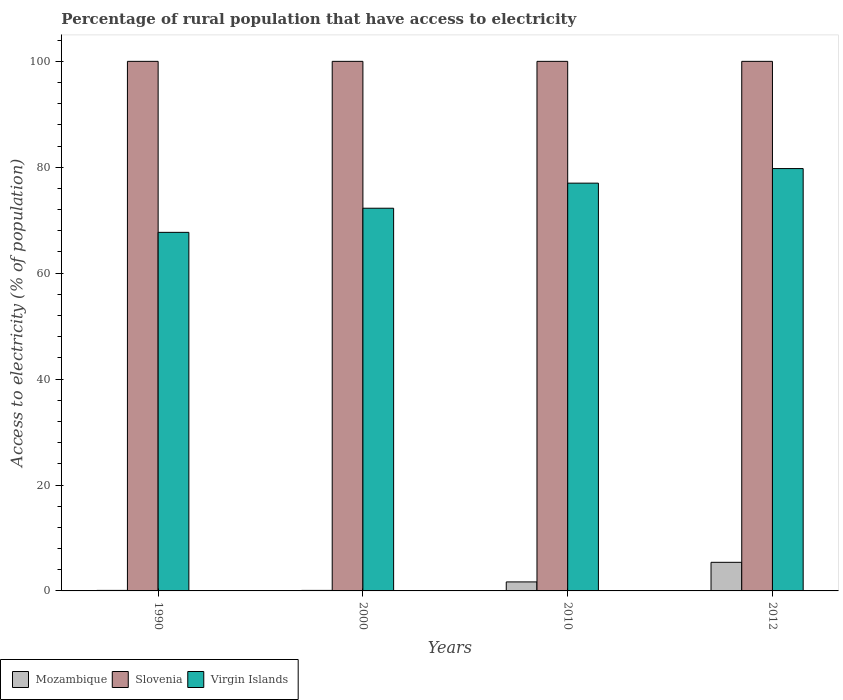Are the number of bars per tick equal to the number of legend labels?
Offer a very short reply. Yes. How many bars are there on the 3rd tick from the left?
Give a very brief answer. 3. How many bars are there on the 4th tick from the right?
Provide a succinct answer. 3. What is the label of the 4th group of bars from the left?
Provide a short and direct response. 2012. What is the percentage of rural population that have access to electricity in Virgin Islands in 2010?
Offer a very short reply. 77. Across all years, what is the maximum percentage of rural population that have access to electricity in Virgin Islands?
Ensure brevity in your answer.  79.75. Across all years, what is the minimum percentage of rural population that have access to electricity in Slovenia?
Your answer should be compact. 100. What is the total percentage of rural population that have access to electricity in Mozambique in the graph?
Your answer should be compact. 7.3. What is the difference between the percentage of rural population that have access to electricity in Virgin Islands in 2000 and that in 2010?
Your response must be concise. -4.73. What is the difference between the percentage of rural population that have access to electricity in Mozambique in 2000 and the percentage of rural population that have access to electricity in Virgin Islands in 1990?
Provide a succinct answer. -67.61. What is the average percentage of rural population that have access to electricity in Virgin Islands per year?
Make the answer very short. 74.18. In the year 2000, what is the difference between the percentage of rural population that have access to electricity in Mozambique and percentage of rural population that have access to electricity in Slovenia?
Your answer should be compact. -99.9. What is the ratio of the percentage of rural population that have access to electricity in Mozambique in 2000 to that in 2010?
Your response must be concise. 0.06. Is the percentage of rural population that have access to electricity in Mozambique in 1990 less than that in 2010?
Ensure brevity in your answer.  Yes. What is the difference between the highest and the second highest percentage of rural population that have access to electricity in Virgin Islands?
Your answer should be compact. 2.75. What is the difference between the highest and the lowest percentage of rural population that have access to electricity in Mozambique?
Offer a terse response. 5.3. What does the 1st bar from the left in 2012 represents?
Make the answer very short. Mozambique. What does the 2nd bar from the right in 2012 represents?
Make the answer very short. Slovenia. Is it the case that in every year, the sum of the percentage of rural population that have access to electricity in Mozambique and percentage of rural population that have access to electricity in Slovenia is greater than the percentage of rural population that have access to electricity in Virgin Islands?
Keep it short and to the point. Yes. Are all the bars in the graph horizontal?
Offer a terse response. No. Are the values on the major ticks of Y-axis written in scientific E-notation?
Keep it short and to the point. No. Does the graph contain any zero values?
Offer a terse response. No. How are the legend labels stacked?
Your response must be concise. Horizontal. What is the title of the graph?
Your answer should be very brief. Percentage of rural population that have access to electricity. What is the label or title of the X-axis?
Offer a very short reply. Years. What is the label or title of the Y-axis?
Provide a succinct answer. Access to electricity (% of population). What is the Access to electricity (% of population) in Mozambique in 1990?
Provide a short and direct response. 0.1. What is the Access to electricity (% of population) in Slovenia in 1990?
Offer a very short reply. 100. What is the Access to electricity (% of population) of Virgin Islands in 1990?
Offer a terse response. 67.71. What is the Access to electricity (% of population) in Slovenia in 2000?
Make the answer very short. 100. What is the Access to electricity (% of population) in Virgin Islands in 2000?
Keep it short and to the point. 72.27. What is the Access to electricity (% of population) of Virgin Islands in 2010?
Your answer should be very brief. 77. What is the Access to electricity (% of population) in Mozambique in 2012?
Make the answer very short. 5.4. What is the Access to electricity (% of population) of Virgin Islands in 2012?
Ensure brevity in your answer.  79.75. Across all years, what is the maximum Access to electricity (% of population) of Slovenia?
Ensure brevity in your answer.  100. Across all years, what is the maximum Access to electricity (% of population) in Virgin Islands?
Your response must be concise. 79.75. Across all years, what is the minimum Access to electricity (% of population) in Slovenia?
Offer a very short reply. 100. Across all years, what is the minimum Access to electricity (% of population) in Virgin Islands?
Offer a terse response. 67.71. What is the total Access to electricity (% of population) of Mozambique in the graph?
Your answer should be very brief. 7.3. What is the total Access to electricity (% of population) of Virgin Islands in the graph?
Provide a short and direct response. 296.73. What is the difference between the Access to electricity (% of population) in Slovenia in 1990 and that in 2000?
Offer a terse response. 0. What is the difference between the Access to electricity (% of population) of Virgin Islands in 1990 and that in 2000?
Provide a succinct answer. -4.55. What is the difference between the Access to electricity (% of population) in Virgin Islands in 1990 and that in 2010?
Keep it short and to the point. -9.29. What is the difference between the Access to electricity (% of population) in Mozambique in 1990 and that in 2012?
Your response must be concise. -5.3. What is the difference between the Access to electricity (% of population) in Slovenia in 1990 and that in 2012?
Your response must be concise. 0. What is the difference between the Access to electricity (% of population) of Virgin Islands in 1990 and that in 2012?
Provide a succinct answer. -12.04. What is the difference between the Access to electricity (% of population) in Virgin Islands in 2000 and that in 2010?
Provide a succinct answer. -4.74. What is the difference between the Access to electricity (% of population) in Slovenia in 2000 and that in 2012?
Ensure brevity in your answer.  0. What is the difference between the Access to electricity (% of population) in Virgin Islands in 2000 and that in 2012?
Your response must be concise. -7.49. What is the difference between the Access to electricity (% of population) in Mozambique in 2010 and that in 2012?
Ensure brevity in your answer.  -3.7. What is the difference between the Access to electricity (% of population) in Virgin Islands in 2010 and that in 2012?
Make the answer very short. -2.75. What is the difference between the Access to electricity (% of population) in Mozambique in 1990 and the Access to electricity (% of population) in Slovenia in 2000?
Your response must be concise. -99.9. What is the difference between the Access to electricity (% of population) of Mozambique in 1990 and the Access to electricity (% of population) of Virgin Islands in 2000?
Offer a terse response. -72.17. What is the difference between the Access to electricity (% of population) of Slovenia in 1990 and the Access to electricity (% of population) of Virgin Islands in 2000?
Give a very brief answer. 27.73. What is the difference between the Access to electricity (% of population) in Mozambique in 1990 and the Access to electricity (% of population) in Slovenia in 2010?
Ensure brevity in your answer.  -99.9. What is the difference between the Access to electricity (% of population) of Mozambique in 1990 and the Access to electricity (% of population) of Virgin Islands in 2010?
Ensure brevity in your answer.  -76.9. What is the difference between the Access to electricity (% of population) in Mozambique in 1990 and the Access to electricity (% of population) in Slovenia in 2012?
Your answer should be compact. -99.9. What is the difference between the Access to electricity (% of population) in Mozambique in 1990 and the Access to electricity (% of population) in Virgin Islands in 2012?
Your answer should be very brief. -79.65. What is the difference between the Access to electricity (% of population) of Slovenia in 1990 and the Access to electricity (% of population) of Virgin Islands in 2012?
Provide a succinct answer. 20.25. What is the difference between the Access to electricity (% of population) in Mozambique in 2000 and the Access to electricity (% of population) in Slovenia in 2010?
Your answer should be very brief. -99.9. What is the difference between the Access to electricity (% of population) in Mozambique in 2000 and the Access to electricity (% of population) in Virgin Islands in 2010?
Give a very brief answer. -76.9. What is the difference between the Access to electricity (% of population) in Slovenia in 2000 and the Access to electricity (% of population) in Virgin Islands in 2010?
Offer a very short reply. 23. What is the difference between the Access to electricity (% of population) of Mozambique in 2000 and the Access to electricity (% of population) of Slovenia in 2012?
Your answer should be very brief. -99.9. What is the difference between the Access to electricity (% of population) in Mozambique in 2000 and the Access to electricity (% of population) in Virgin Islands in 2012?
Your answer should be very brief. -79.65. What is the difference between the Access to electricity (% of population) in Slovenia in 2000 and the Access to electricity (% of population) in Virgin Islands in 2012?
Your answer should be compact. 20.25. What is the difference between the Access to electricity (% of population) in Mozambique in 2010 and the Access to electricity (% of population) in Slovenia in 2012?
Offer a terse response. -98.3. What is the difference between the Access to electricity (% of population) in Mozambique in 2010 and the Access to electricity (% of population) in Virgin Islands in 2012?
Provide a short and direct response. -78.05. What is the difference between the Access to electricity (% of population) of Slovenia in 2010 and the Access to electricity (% of population) of Virgin Islands in 2012?
Offer a terse response. 20.25. What is the average Access to electricity (% of population) in Mozambique per year?
Provide a short and direct response. 1.82. What is the average Access to electricity (% of population) of Slovenia per year?
Give a very brief answer. 100. What is the average Access to electricity (% of population) of Virgin Islands per year?
Provide a succinct answer. 74.18. In the year 1990, what is the difference between the Access to electricity (% of population) in Mozambique and Access to electricity (% of population) in Slovenia?
Ensure brevity in your answer.  -99.9. In the year 1990, what is the difference between the Access to electricity (% of population) of Mozambique and Access to electricity (% of population) of Virgin Islands?
Your response must be concise. -67.61. In the year 1990, what is the difference between the Access to electricity (% of population) of Slovenia and Access to electricity (% of population) of Virgin Islands?
Make the answer very short. 32.29. In the year 2000, what is the difference between the Access to electricity (% of population) of Mozambique and Access to electricity (% of population) of Slovenia?
Ensure brevity in your answer.  -99.9. In the year 2000, what is the difference between the Access to electricity (% of population) in Mozambique and Access to electricity (% of population) in Virgin Islands?
Offer a very short reply. -72.17. In the year 2000, what is the difference between the Access to electricity (% of population) in Slovenia and Access to electricity (% of population) in Virgin Islands?
Keep it short and to the point. 27.73. In the year 2010, what is the difference between the Access to electricity (% of population) in Mozambique and Access to electricity (% of population) in Slovenia?
Offer a very short reply. -98.3. In the year 2010, what is the difference between the Access to electricity (% of population) of Mozambique and Access to electricity (% of population) of Virgin Islands?
Offer a terse response. -75.3. In the year 2012, what is the difference between the Access to electricity (% of population) in Mozambique and Access to electricity (% of population) in Slovenia?
Your response must be concise. -94.6. In the year 2012, what is the difference between the Access to electricity (% of population) in Mozambique and Access to electricity (% of population) in Virgin Islands?
Your response must be concise. -74.35. In the year 2012, what is the difference between the Access to electricity (% of population) in Slovenia and Access to electricity (% of population) in Virgin Islands?
Offer a terse response. 20.25. What is the ratio of the Access to electricity (% of population) in Virgin Islands in 1990 to that in 2000?
Your answer should be compact. 0.94. What is the ratio of the Access to electricity (% of population) in Mozambique in 1990 to that in 2010?
Keep it short and to the point. 0.06. What is the ratio of the Access to electricity (% of population) in Virgin Islands in 1990 to that in 2010?
Your response must be concise. 0.88. What is the ratio of the Access to electricity (% of population) of Mozambique in 1990 to that in 2012?
Your answer should be very brief. 0.02. What is the ratio of the Access to electricity (% of population) in Slovenia in 1990 to that in 2012?
Provide a succinct answer. 1. What is the ratio of the Access to electricity (% of population) in Virgin Islands in 1990 to that in 2012?
Your answer should be compact. 0.85. What is the ratio of the Access to electricity (% of population) of Mozambique in 2000 to that in 2010?
Provide a succinct answer. 0.06. What is the ratio of the Access to electricity (% of population) of Virgin Islands in 2000 to that in 2010?
Give a very brief answer. 0.94. What is the ratio of the Access to electricity (% of population) in Mozambique in 2000 to that in 2012?
Give a very brief answer. 0.02. What is the ratio of the Access to electricity (% of population) of Virgin Islands in 2000 to that in 2012?
Offer a very short reply. 0.91. What is the ratio of the Access to electricity (% of population) in Mozambique in 2010 to that in 2012?
Offer a terse response. 0.31. What is the ratio of the Access to electricity (% of population) of Slovenia in 2010 to that in 2012?
Offer a terse response. 1. What is the ratio of the Access to electricity (% of population) in Virgin Islands in 2010 to that in 2012?
Provide a short and direct response. 0.97. What is the difference between the highest and the second highest Access to electricity (% of population) in Slovenia?
Make the answer very short. 0. What is the difference between the highest and the second highest Access to electricity (% of population) of Virgin Islands?
Keep it short and to the point. 2.75. What is the difference between the highest and the lowest Access to electricity (% of population) in Slovenia?
Ensure brevity in your answer.  0. What is the difference between the highest and the lowest Access to electricity (% of population) in Virgin Islands?
Offer a terse response. 12.04. 